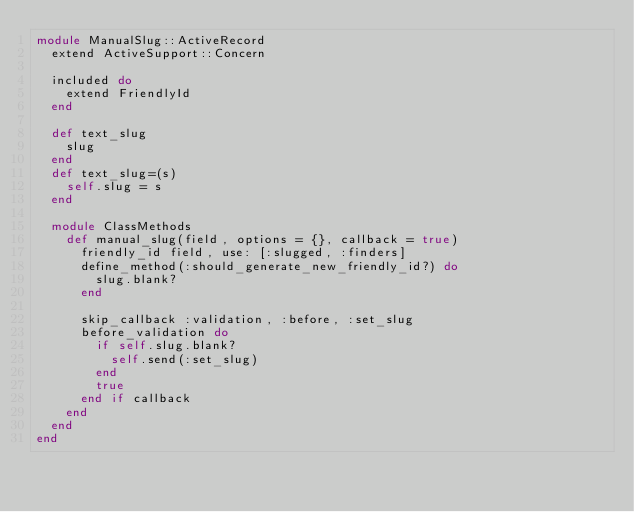Convert code to text. <code><loc_0><loc_0><loc_500><loc_500><_Ruby_>module ManualSlug::ActiveRecord
  extend ActiveSupport::Concern

  included do
    extend FriendlyId
  end

  def text_slug
    slug
  end
  def text_slug=(s)
    self.slug = s
  end

  module ClassMethods
    def manual_slug(field, options = {}, callback = true)
      friendly_id field, use: [:slugged, :finders]
      define_method(:should_generate_new_friendly_id?) do
        slug.blank?
      end

      skip_callback :validation, :before, :set_slug
      before_validation do
        if self.slug.blank?
          self.send(:set_slug)
        end
        true
      end if callback
    end
  end
end
 
</code> 